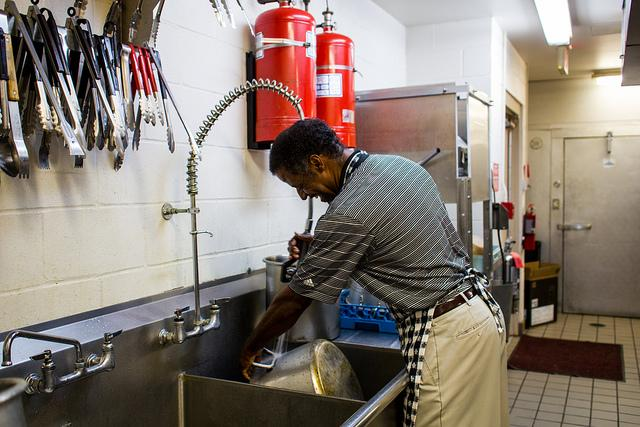What items are hanging on the wall?

Choices:
A) family crests
B) portraits
C) posters
D) tongs tongs 